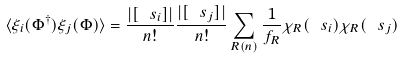<formula> <loc_0><loc_0><loc_500><loc_500>\langle \xi _ { i } ( \Phi ^ { \dagger } ) \xi _ { j } ( \Phi ) \rangle = \frac { | [ \ s _ { i } ] | } { n ! } \frac { | [ \ s _ { j } ] | } { n ! } \sum _ { R ( n ) } \frac { 1 } { f _ { R } } \chi _ { R } ( \ s _ { i } ) \chi _ { R } ( \ s _ { j } )</formula> 